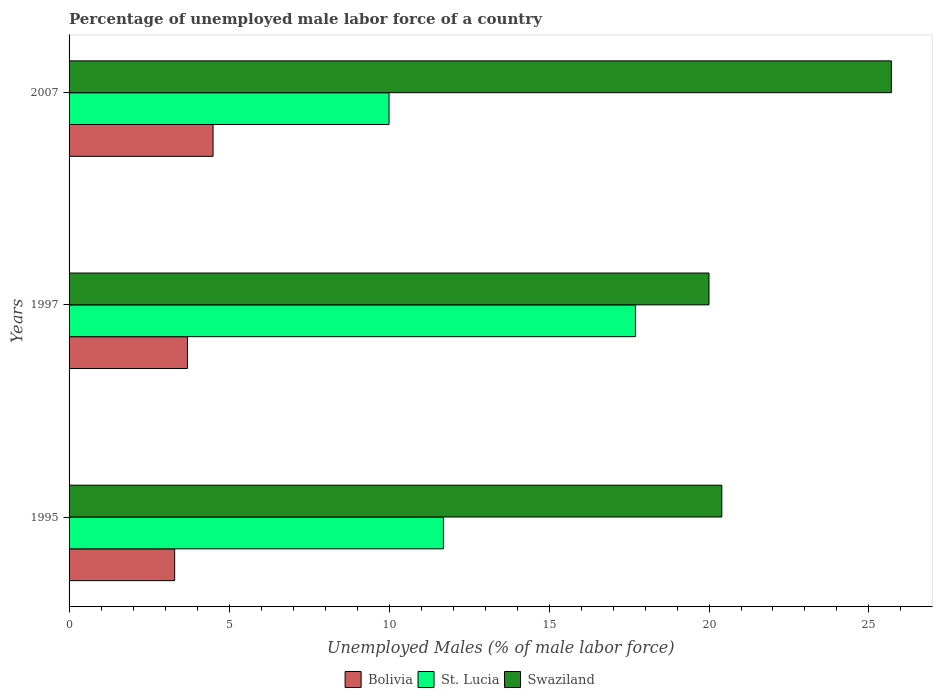Across all years, what is the maximum percentage of unemployed male labor force in Swaziland?
Your response must be concise. 25.7. In which year was the percentage of unemployed male labor force in St. Lucia maximum?
Make the answer very short. 1997. In which year was the percentage of unemployed male labor force in Swaziland minimum?
Your response must be concise. 1997. What is the total percentage of unemployed male labor force in St. Lucia in the graph?
Provide a short and direct response. 39.4. What is the difference between the percentage of unemployed male labor force in Swaziland in 1995 and that in 2007?
Provide a short and direct response. -5.3. What is the difference between the percentage of unemployed male labor force in Swaziland in 1995 and the percentage of unemployed male labor force in St. Lucia in 1997?
Give a very brief answer. 2.7. What is the average percentage of unemployed male labor force in Swaziland per year?
Provide a succinct answer. 22.03. In the year 1995, what is the difference between the percentage of unemployed male labor force in St. Lucia and percentage of unemployed male labor force in Swaziland?
Provide a short and direct response. -8.7. In how many years, is the percentage of unemployed male labor force in Bolivia greater than 16 %?
Your answer should be very brief. 0. What is the ratio of the percentage of unemployed male labor force in Swaziland in 1995 to that in 2007?
Provide a succinct answer. 0.79. Is the difference between the percentage of unemployed male labor force in St. Lucia in 1997 and 2007 greater than the difference between the percentage of unemployed male labor force in Swaziland in 1997 and 2007?
Give a very brief answer. Yes. What is the difference between the highest and the second highest percentage of unemployed male labor force in Swaziland?
Ensure brevity in your answer.  5.3. What is the difference between the highest and the lowest percentage of unemployed male labor force in Bolivia?
Your response must be concise. 1.2. What does the 3rd bar from the bottom in 1997 represents?
Make the answer very short. Swaziland. How many bars are there?
Provide a succinct answer. 9. Are all the bars in the graph horizontal?
Offer a very short reply. Yes. Where does the legend appear in the graph?
Your answer should be very brief. Bottom center. How many legend labels are there?
Ensure brevity in your answer.  3. How are the legend labels stacked?
Provide a succinct answer. Horizontal. What is the title of the graph?
Make the answer very short. Percentage of unemployed male labor force of a country. Does "Ecuador" appear as one of the legend labels in the graph?
Provide a short and direct response. No. What is the label or title of the X-axis?
Offer a terse response. Unemployed Males (% of male labor force). What is the label or title of the Y-axis?
Offer a very short reply. Years. What is the Unemployed Males (% of male labor force) in Bolivia in 1995?
Give a very brief answer. 3.3. What is the Unemployed Males (% of male labor force) of St. Lucia in 1995?
Provide a succinct answer. 11.7. What is the Unemployed Males (% of male labor force) in Swaziland in 1995?
Provide a short and direct response. 20.4. What is the Unemployed Males (% of male labor force) of Bolivia in 1997?
Give a very brief answer. 3.7. What is the Unemployed Males (% of male labor force) in St. Lucia in 1997?
Provide a short and direct response. 17.7. What is the Unemployed Males (% of male labor force) in Swaziland in 1997?
Ensure brevity in your answer.  20. What is the Unemployed Males (% of male labor force) of Bolivia in 2007?
Offer a terse response. 4.5. What is the Unemployed Males (% of male labor force) in St. Lucia in 2007?
Ensure brevity in your answer.  10. What is the Unemployed Males (% of male labor force) of Swaziland in 2007?
Make the answer very short. 25.7. Across all years, what is the maximum Unemployed Males (% of male labor force) in St. Lucia?
Offer a very short reply. 17.7. Across all years, what is the maximum Unemployed Males (% of male labor force) of Swaziland?
Your response must be concise. 25.7. Across all years, what is the minimum Unemployed Males (% of male labor force) of Bolivia?
Your answer should be compact. 3.3. Across all years, what is the minimum Unemployed Males (% of male labor force) of St. Lucia?
Provide a succinct answer. 10. What is the total Unemployed Males (% of male labor force) in St. Lucia in the graph?
Provide a succinct answer. 39.4. What is the total Unemployed Males (% of male labor force) in Swaziland in the graph?
Provide a succinct answer. 66.1. What is the difference between the Unemployed Males (% of male labor force) of Swaziland in 1995 and that in 1997?
Offer a very short reply. 0.4. What is the difference between the Unemployed Males (% of male labor force) in Bolivia in 1997 and that in 2007?
Offer a terse response. -0.8. What is the difference between the Unemployed Males (% of male labor force) of St. Lucia in 1997 and that in 2007?
Make the answer very short. 7.7. What is the difference between the Unemployed Males (% of male labor force) of Swaziland in 1997 and that in 2007?
Provide a succinct answer. -5.7. What is the difference between the Unemployed Males (% of male labor force) in Bolivia in 1995 and the Unemployed Males (% of male labor force) in St. Lucia in 1997?
Your response must be concise. -14.4. What is the difference between the Unemployed Males (% of male labor force) of Bolivia in 1995 and the Unemployed Males (% of male labor force) of Swaziland in 1997?
Offer a very short reply. -16.7. What is the difference between the Unemployed Males (% of male labor force) of Bolivia in 1995 and the Unemployed Males (% of male labor force) of St. Lucia in 2007?
Ensure brevity in your answer.  -6.7. What is the difference between the Unemployed Males (% of male labor force) of Bolivia in 1995 and the Unemployed Males (% of male labor force) of Swaziland in 2007?
Offer a very short reply. -22.4. What is the difference between the Unemployed Males (% of male labor force) of St. Lucia in 1995 and the Unemployed Males (% of male labor force) of Swaziland in 2007?
Offer a terse response. -14. What is the difference between the Unemployed Males (% of male labor force) in Bolivia in 1997 and the Unemployed Males (% of male labor force) in St. Lucia in 2007?
Your answer should be very brief. -6.3. What is the difference between the Unemployed Males (% of male labor force) of St. Lucia in 1997 and the Unemployed Males (% of male labor force) of Swaziland in 2007?
Provide a succinct answer. -8. What is the average Unemployed Males (% of male labor force) in Bolivia per year?
Keep it short and to the point. 3.83. What is the average Unemployed Males (% of male labor force) in St. Lucia per year?
Provide a short and direct response. 13.13. What is the average Unemployed Males (% of male labor force) of Swaziland per year?
Give a very brief answer. 22.03. In the year 1995, what is the difference between the Unemployed Males (% of male labor force) of Bolivia and Unemployed Males (% of male labor force) of St. Lucia?
Provide a short and direct response. -8.4. In the year 1995, what is the difference between the Unemployed Males (% of male labor force) of Bolivia and Unemployed Males (% of male labor force) of Swaziland?
Keep it short and to the point. -17.1. In the year 1997, what is the difference between the Unemployed Males (% of male labor force) of Bolivia and Unemployed Males (% of male labor force) of St. Lucia?
Your answer should be compact. -14. In the year 1997, what is the difference between the Unemployed Males (% of male labor force) in Bolivia and Unemployed Males (% of male labor force) in Swaziland?
Offer a very short reply. -16.3. In the year 1997, what is the difference between the Unemployed Males (% of male labor force) in St. Lucia and Unemployed Males (% of male labor force) in Swaziland?
Give a very brief answer. -2.3. In the year 2007, what is the difference between the Unemployed Males (% of male labor force) in Bolivia and Unemployed Males (% of male labor force) in Swaziland?
Keep it short and to the point. -21.2. In the year 2007, what is the difference between the Unemployed Males (% of male labor force) of St. Lucia and Unemployed Males (% of male labor force) of Swaziland?
Your answer should be very brief. -15.7. What is the ratio of the Unemployed Males (% of male labor force) in Bolivia in 1995 to that in 1997?
Your answer should be compact. 0.89. What is the ratio of the Unemployed Males (% of male labor force) of St. Lucia in 1995 to that in 1997?
Ensure brevity in your answer.  0.66. What is the ratio of the Unemployed Males (% of male labor force) of Bolivia in 1995 to that in 2007?
Your response must be concise. 0.73. What is the ratio of the Unemployed Males (% of male labor force) in St. Lucia in 1995 to that in 2007?
Offer a very short reply. 1.17. What is the ratio of the Unemployed Males (% of male labor force) in Swaziland in 1995 to that in 2007?
Offer a very short reply. 0.79. What is the ratio of the Unemployed Males (% of male labor force) of Bolivia in 1997 to that in 2007?
Provide a succinct answer. 0.82. What is the ratio of the Unemployed Males (% of male labor force) of St. Lucia in 1997 to that in 2007?
Ensure brevity in your answer.  1.77. What is the ratio of the Unemployed Males (% of male labor force) in Swaziland in 1997 to that in 2007?
Make the answer very short. 0.78. What is the difference between the highest and the second highest Unemployed Males (% of male labor force) in St. Lucia?
Your answer should be very brief. 6. What is the difference between the highest and the second highest Unemployed Males (% of male labor force) in Swaziland?
Keep it short and to the point. 5.3. What is the difference between the highest and the lowest Unemployed Males (% of male labor force) of Bolivia?
Your answer should be very brief. 1.2. What is the difference between the highest and the lowest Unemployed Males (% of male labor force) of St. Lucia?
Give a very brief answer. 7.7. What is the difference between the highest and the lowest Unemployed Males (% of male labor force) of Swaziland?
Your response must be concise. 5.7. 